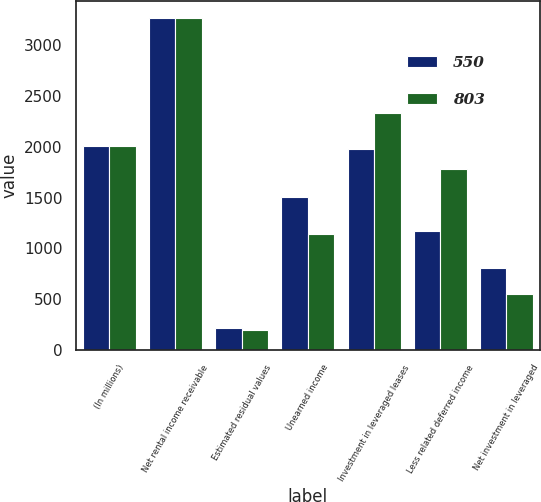<chart> <loc_0><loc_0><loc_500><loc_500><stacked_bar_chart><ecel><fcel>(In millions)<fcel>Net rental income receivable<fcel>Estimated residual values<fcel>Unearned income<fcel>Investment in leveraged leases<fcel>Less related deferred income<fcel>Net investment in leveraged<nl><fcel>550<fcel>2007<fcel>3264<fcel>222<fcel>1506<fcel>1980<fcel>1177<fcel>803<nl><fcel>803<fcel>2006<fcel>3272<fcel>196<fcel>1139<fcel>2329<fcel>1779<fcel>550<nl></chart> 